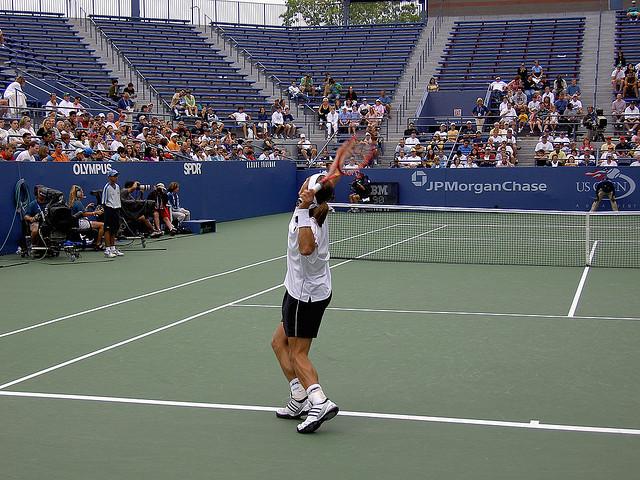What sport are they playing?
Quick response, please. Tennis. How many stripes on the players shoe?
Keep it brief. 3. What is the logo that begins with J?
Answer briefly. Jpmorgan chase. 